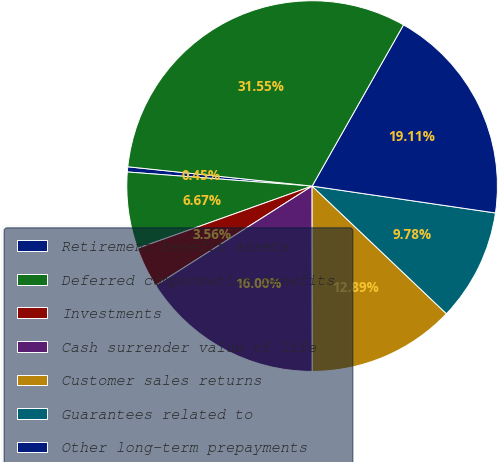<chart> <loc_0><loc_0><loc_500><loc_500><pie_chart><fcel>Retirement benefit assets<fcel>Deferred compensation benefits<fcel>Investments<fcel>Cash surrender value of life<fcel>Customer sales returns<fcel>Guarantees related to<fcel>Other long-term prepayments<fcel>Total other assets<nl><fcel>0.45%<fcel>6.67%<fcel>3.56%<fcel>16.0%<fcel>12.89%<fcel>9.78%<fcel>19.11%<fcel>31.55%<nl></chart> 